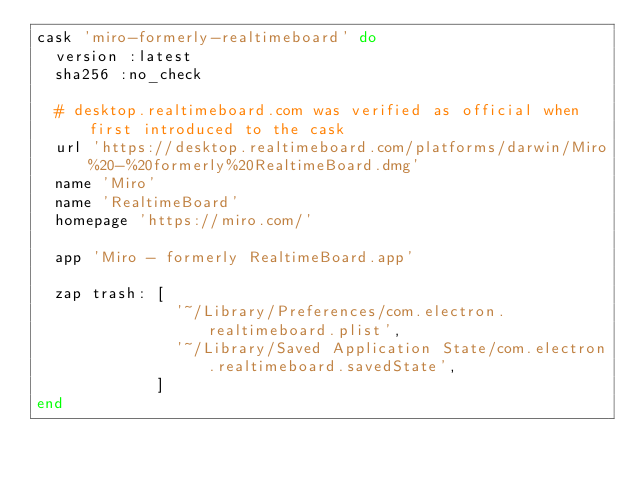Convert code to text. <code><loc_0><loc_0><loc_500><loc_500><_Ruby_>cask 'miro-formerly-realtimeboard' do
  version :latest
  sha256 :no_check

  # desktop.realtimeboard.com was verified as official when first introduced to the cask
  url 'https://desktop.realtimeboard.com/platforms/darwin/Miro%20-%20formerly%20RealtimeBoard.dmg'
  name 'Miro'
  name 'RealtimeBoard'
  homepage 'https://miro.com/'

  app 'Miro - formerly RealtimeBoard.app'

  zap trash: [
               '~/Library/Preferences/com.electron.realtimeboard.plist',
               '~/Library/Saved Application State/com.electron.realtimeboard.savedState',
             ]
end
</code> 